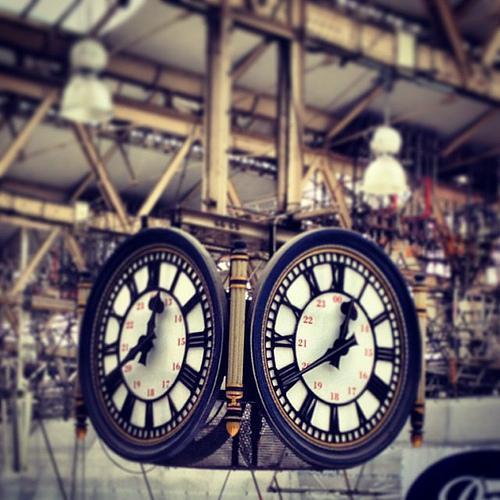How many clocks are in the photo?
Give a very brief answer. 2. How many second hands are on each clock?
Give a very brief answer. 0. 